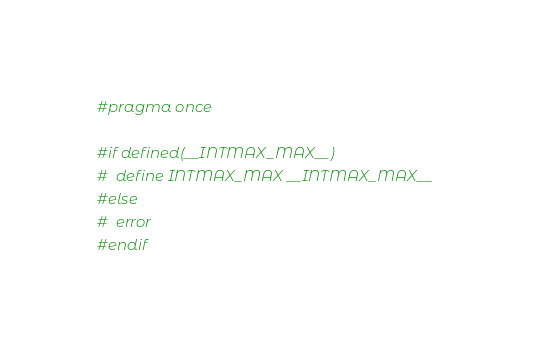Convert code to text. <code><loc_0><loc_0><loc_500><loc_500><_C_>#pragma once

#if defined(__INTMAX_MAX__)
#  define INTMAX_MAX __INTMAX_MAX__
#else
#  error
#endif
</code> 